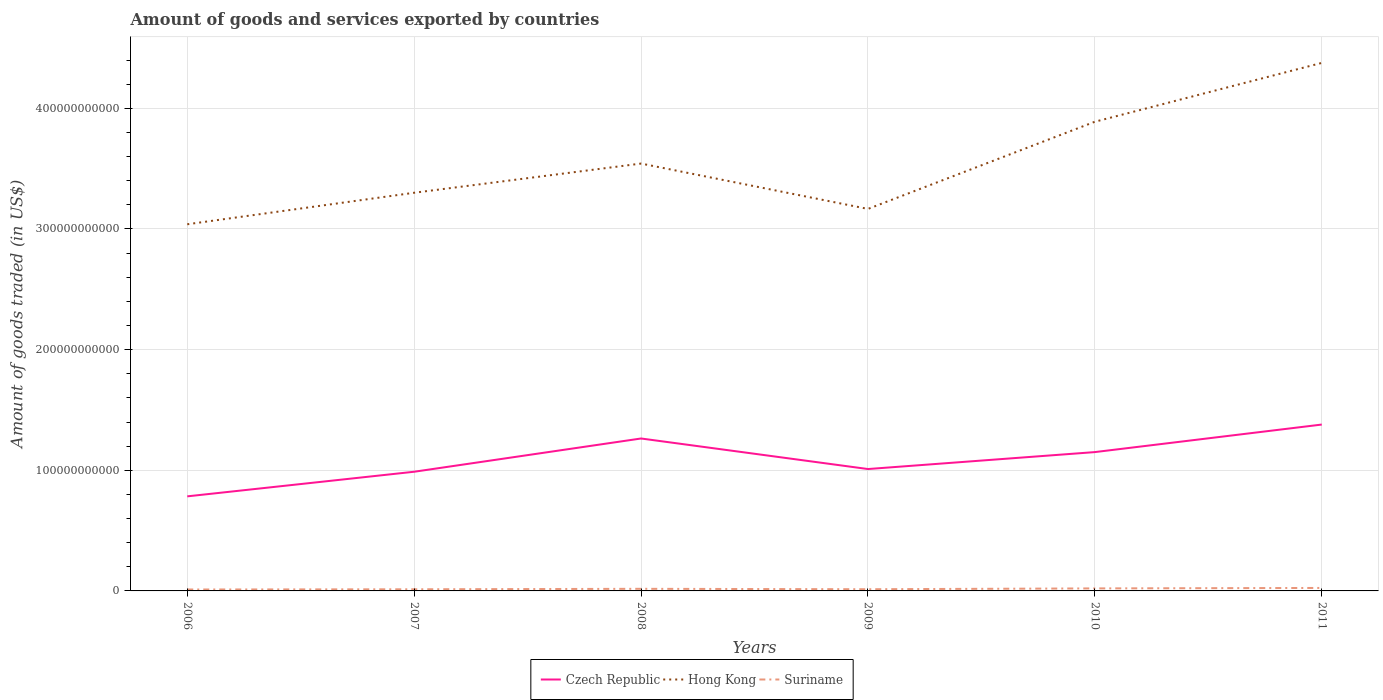How many different coloured lines are there?
Provide a succinct answer. 3. Across all years, what is the maximum total amount of goods and services exported in Hong Kong?
Your response must be concise. 3.04e+11. What is the total total amount of goods and services exported in Czech Republic in the graph?
Provide a short and direct response. -2.76e+1. What is the difference between the highest and the second highest total amount of goods and services exported in Suriname?
Offer a terse response. 1.29e+09. How many years are there in the graph?
Give a very brief answer. 6. What is the difference between two consecutive major ticks on the Y-axis?
Your answer should be very brief. 1.00e+11. Are the values on the major ticks of Y-axis written in scientific E-notation?
Provide a succinct answer. No. How many legend labels are there?
Your response must be concise. 3. How are the legend labels stacked?
Keep it short and to the point. Horizontal. What is the title of the graph?
Provide a short and direct response. Amount of goods and services exported by countries. What is the label or title of the Y-axis?
Your answer should be compact. Amount of goods traded (in US$). What is the Amount of goods traded (in US$) in Czech Republic in 2006?
Give a very brief answer. 7.84e+1. What is the Amount of goods traded (in US$) of Hong Kong in 2006?
Give a very brief answer. 3.04e+11. What is the Amount of goods traded (in US$) of Suriname in 2006?
Your answer should be compact. 1.17e+09. What is the Amount of goods traded (in US$) of Czech Republic in 2007?
Your answer should be very brief. 9.88e+1. What is the Amount of goods traded (in US$) of Hong Kong in 2007?
Offer a terse response. 3.30e+11. What is the Amount of goods traded (in US$) of Suriname in 2007?
Your answer should be compact. 1.36e+09. What is the Amount of goods traded (in US$) in Czech Republic in 2008?
Offer a very short reply. 1.26e+11. What is the Amount of goods traded (in US$) in Hong Kong in 2008?
Ensure brevity in your answer.  3.54e+11. What is the Amount of goods traded (in US$) in Suriname in 2008?
Provide a short and direct response. 1.74e+09. What is the Amount of goods traded (in US$) of Czech Republic in 2009?
Keep it short and to the point. 1.01e+11. What is the Amount of goods traded (in US$) in Hong Kong in 2009?
Your answer should be compact. 3.17e+11. What is the Amount of goods traded (in US$) in Suriname in 2009?
Keep it short and to the point. 1.40e+09. What is the Amount of goods traded (in US$) in Czech Republic in 2010?
Make the answer very short. 1.15e+11. What is the Amount of goods traded (in US$) in Hong Kong in 2010?
Keep it short and to the point. 3.89e+11. What is the Amount of goods traded (in US$) of Suriname in 2010?
Offer a terse response. 2.08e+09. What is the Amount of goods traded (in US$) in Czech Republic in 2011?
Keep it short and to the point. 1.38e+11. What is the Amount of goods traded (in US$) of Hong Kong in 2011?
Provide a succinct answer. 4.38e+11. What is the Amount of goods traded (in US$) of Suriname in 2011?
Provide a succinct answer. 2.47e+09. Across all years, what is the maximum Amount of goods traded (in US$) in Czech Republic?
Offer a very short reply. 1.38e+11. Across all years, what is the maximum Amount of goods traded (in US$) in Hong Kong?
Your answer should be compact. 4.38e+11. Across all years, what is the maximum Amount of goods traded (in US$) in Suriname?
Provide a short and direct response. 2.47e+09. Across all years, what is the minimum Amount of goods traded (in US$) of Czech Republic?
Provide a short and direct response. 7.84e+1. Across all years, what is the minimum Amount of goods traded (in US$) of Hong Kong?
Offer a terse response. 3.04e+11. Across all years, what is the minimum Amount of goods traded (in US$) in Suriname?
Give a very brief answer. 1.17e+09. What is the total Amount of goods traded (in US$) of Czech Republic in the graph?
Provide a short and direct response. 6.58e+11. What is the total Amount of goods traded (in US$) in Hong Kong in the graph?
Your answer should be very brief. 2.13e+12. What is the total Amount of goods traded (in US$) of Suriname in the graph?
Offer a very short reply. 1.02e+1. What is the difference between the Amount of goods traded (in US$) in Czech Republic in 2006 and that in 2007?
Give a very brief answer. -2.04e+1. What is the difference between the Amount of goods traded (in US$) in Hong Kong in 2006 and that in 2007?
Give a very brief answer. -2.61e+1. What is the difference between the Amount of goods traded (in US$) of Suriname in 2006 and that in 2007?
Offer a very short reply. -1.84e+08. What is the difference between the Amount of goods traded (in US$) of Czech Republic in 2006 and that in 2008?
Offer a very short reply. -4.80e+1. What is the difference between the Amount of goods traded (in US$) in Hong Kong in 2006 and that in 2008?
Your response must be concise. -5.03e+1. What is the difference between the Amount of goods traded (in US$) of Suriname in 2006 and that in 2008?
Make the answer very short. -5.69e+08. What is the difference between the Amount of goods traded (in US$) of Czech Republic in 2006 and that in 2009?
Give a very brief answer. -2.26e+1. What is the difference between the Amount of goods traded (in US$) of Hong Kong in 2006 and that in 2009?
Provide a succinct answer. -1.27e+1. What is the difference between the Amount of goods traded (in US$) in Suriname in 2006 and that in 2009?
Provide a short and direct response. -2.27e+08. What is the difference between the Amount of goods traded (in US$) in Czech Republic in 2006 and that in 2010?
Your response must be concise. -3.67e+1. What is the difference between the Amount of goods traded (in US$) in Hong Kong in 2006 and that in 2010?
Your answer should be very brief. -8.50e+1. What is the difference between the Amount of goods traded (in US$) of Suriname in 2006 and that in 2010?
Offer a very short reply. -9.10e+08. What is the difference between the Amount of goods traded (in US$) of Czech Republic in 2006 and that in 2011?
Your answer should be compact. -5.95e+1. What is the difference between the Amount of goods traded (in US$) in Hong Kong in 2006 and that in 2011?
Keep it short and to the point. -1.34e+11. What is the difference between the Amount of goods traded (in US$) of Suriname in 2006 and that in 2011?
Make the answer very short. -1.29e+09. What is the difference between the Amount of goods traded (in US$) of Czech Republic in 2007 and that in 2008?
Your answer should be very brief. -2.76e+1. What is the difference between the Amount of goods traded (in US$) in Hong Kong in 2007 and that in 2008?
Your answer should be very brief. -2.42e+1. What is the difference between the Amount of goods traded (in US$) in Suriname in 2007 and that in 2008?
Your answer should be compact. -3.84e+08. What is the difference between the Amount of goods traded (in US$) in Czech Republic in 2007 and that in 2009?
Offer a very short reply. -2.24e+09. What is the difference between the Amount of goods traded (in US$) of Hong Kong in 2007 and that in 2009?
Offer a very short reply. 1.34e+1. What is the difference between the Amount of goods traded (in US$) of Suriname in 2007 and that in 2009?
Offer a terse response. -4.28e+07. What is the difference between the Amount of goods traded (in US$) in Czech Republic in 2007 and that in 2010?
Keep it short and to the point. -1.63e+1. What is the difference between the Amount of goods traded (in US$) in Hong Kong in 2007 and that in 2010?
Make the answer very short. -5.89e+1. What is the difference between the Amount of goods traded (in US$) of Suriname in 2007 and that in 2010?
Provide a succinct answer. -7.25e+08. What is the difference between the Amount of goods traded (in US$) of Czech Republic in 2007 and that in 2011?
Your answer should be compact. -3.91e+1. What is the difference between the Amount of goods traded (in US$) of Hong Kong in 2007 and that in 2011?
Give a very brief answer. -1.08e+11. What is the difference between the Amount of goods traded (in US$) of Suriname in 2007 and that in 2011?
Your answer should be compact. -1.11e+09. What is the difference between the Amount of goods traded (in US$) in Czech Republic in 2008 and that in 2009?
Your answer should be very brief. 2.53e+1. What is the difference between the Amount of goods traded (in US$) in Hong Kong in 2008 and that in 2009?
Your answer should be compact. 3.76e+1. What is the difference between the Amount of goods traded (in US$) of Suriname in 2008 and that in 2009?
Provide a short and direct response. 3.42e+08. What is the difference between the Amount of goods traded (in US$) of Czech Republic in 2008 and that in 2010?
Offer a very short reply. 1.13e+1. What is the difference between the Amount of goods traded (in US$) of Hong Kong in 2008 and that in 2010?
Your response must be concise. -3.47e+1. What is the difference between the Amount of goods traded (in US$) of Suriname in 2008 and that in 2010?
Keep it short and to the point. -3.41e+08. What is the difference between the Amount of goods traded (in US$) in Czech Republic in 2008 and that in 2011?
Ensure brevity in your answer.  -1.15e+1. What is the difference between the Amount of goods traded (in US$) in Hong Kong in 2008 and that in 2011?
Make the answer very short. -8.34e+1. What is the difference between the Amount of goods traded (in US$) in Suriname in 2008 and that in 2011?
Offer a very short reply. -7.23e+08. What is the difference between the Amount of goods traded (in US$) in Czech Republic in 2009 and that in 2010?
Give a very brief answer. -1.40e+1. What is the difference between the Amount of goods traded (in US$) in Hong Kong in 2009 and that in 2010?
Your answer should be compact. -7.23e+1. What is the difference between the Amount of goods traded (in US$) in Suriname in 2009 and that in 2010?
Make the answer very short. -6.82e+08. What is the difference between the Amount of goods traded (in US$) of Czech Republic in 2009 and that in 2011?
Your answer should be compact. -3.69e+1. What is the difference between the Amount of goods traded (in US$) in Hong Kong in 2009 and that in 2011?
Give a very brief answer. -1.21e+11. What is the difference between the Amount of goods traded (in US$) of Suriname in 2009 and that in 2011?
Offer a terse response. -1.06e+09. What is the difference between the Amount of goods traded (in US$) in Czech Republic in 2010 and that in 2011?
Your answer should be very brief. -2.28e+1. What is the difference between the Amount of goods traded (in US$) in Hong Kong in 2010 and that in 2011?
Your answer should be compact. -4.88e+1. What is the difference between the Amount of goods traded (in US$) of Suriname in 2010 and that in 2011?
Provide a short and direct response. -3.83e+08. What is the difference between the Amount of goods traded (in US$) in Czech Republic in 2006 and the Amount of goods traded (in US$) in Hong Kong in 2007?
Your response must be concise. -2.52e+11. What is the difference between the Amount of goods traded (in US$) in Czech Republic in 2006 and the Amount of goods traded (in US$) in Suriname in 2007?
Provide a succinct answer. 7.70e+1. What is the difference between the Amount of goods traded (in US$) in Hong Kong in 2006 and the Amount of goods traded (in US$) in Suriname in 2007?
Offer a very short reply. 3.03e+11. What is the difference between the Amount of goods traded (in US$) in Czech Republic in 2006 and the Amount of goods traded (in US$) in Hong Kong in 2008?
Ensure brevity in your answer.  -2.76e+11. What is the difference between the Amount of goods traded (in US$) of Czech Republic in 2006 and the Amount of goods traded (in US$) of Suriname in 2008?
Give a very brief answer. 7.66e+1. What is the difference between the Amount of goods traded (in US$) of Hong Kong in 2006 and the Amount of goods traded (in US$) of Suriname in 2008?
Your answer should be compact. 3.02e+11. What is the difference between the Amount of goods traded (in US$) in Czech Republic in 2006 and the Amount of goods traded (in US$) in Hong Kong in 2009?
Ensure brevity in your answer.  -2.38e+11. What is the difference between the Amount of goods traded (in US$) of Czech Republic in 2006 and the Amount of goods traded (in US$) of Suriname in 2009?
Offer a very short reply. 7.70e+1. What is the difference between the Amount of goods traded (in US$) of Hong Kong in 2006 and the Amount of goods traded (in US$) of Suriname in 2009?
Give a very brief answer. 3.03e+11. What is the difference between the Amount of goods traded (in US$) of Czech Republic in 2006 and the Amount of goods traded (in US$) of Hong Kong in 2010?
Ensure brevity in your answer.  -3.11e+11. What is the difference between the Amount of goods traded (in US$) of Czech Republic in 2006 and the Amount of goods traded (in US$) of Suriname in 2010?
Provide a succinct answer. 7.63e+1. What is the difference between the Amount of goods traded (in US$) of Hong Kong in 2006 and the Amount of goods traded (in US$) of Suriname in 2010?
Offer a very short reply. 3.02e+11. What is the difference between the Amount of goods traded (in US$) of Czech Republic in 2006 and the Amount of goods traded (in US$) of Hong Kong in 2011?
Provide a short and direct response. -3.59e+11. What is the difference between the Amount of goods traded (in US$) of Czech Republic in 2006 and the Amount of goods traded (in US$) of Suriname in 2011?
Make the answer very short. 7.59e+1. What is the difference between the Amount of goods traded (in US$) of Hong Kong in 2006 and the Amount of goods traded (in US$) of Suriname in 2011?
Offer a very short reply. 3.01e+11. What is the difference between the Amount of goods traded (in US$) of Czech Republic in 2007 and the Amount of goods traded (in US$) of Hong Kong in 2008?
Make the answer very short. -2.55e+11. What is the difference between the Amount of goods traded (in US$) of Czech Republic in 2007 and the Amount of goods traded (in US$) of Suriname in 2008?
Ensure brevity in your answer.  9.70e+1. What is the difference between the Amount of goods traded (in US$) in Hong Kong in 2007 and the Amount of goods traded (in US$) in Suriname in 2008?
Offer a very short reply. 3.28e+11. What is the difference between the Amount of goods traded (in US$) in Czech Republic in 2007 and the Amount of goods traded (in US$) in Hong Kong in 2009?
Your answer should be compact. -2.18e+11. What is the difference between the Amount of goods traded (in US$) in Czech Republic in 2007 and the Amount of goods traded (in US$) in Suriname in 2009?
Provide a short and direct response. 9.74e+1. What is the difference between the Amount of goods traded (in US$) in Hong Kong in 2007 and the Amount of goods traded (in US$) in Suriname in 2009?
Offer a very short reply. 3.29e+11. What is the difference between the Amount of goods traded (in US$) in Czech Republic in 2007 and the Amount of goods traded (in US$) in Hong Kong in 2010?
Make the answer very short. -2.90e+11. What is the difference between the Amount of goods traded (in US$) in Czech Republic in 2007 and the Amount of goods traded (in US$) in Suriname in 2010?
Your answer should be compact. 9.67e+1. What is the difference between the Amount of goods traded (in US$) in Hong Kong in 2007 and the Amount of goods traded (in US$) in Suriname in 2010?
Give a very brief answer. 3.28e+11. What is the difference between the Amount of goods traded (in US$) of Czech Republic in 2007 and the Amount of goods traded (in US$) of Hong Kong in 2011?
Keep it short and to the point. -3.39e+11. What is the difference between the Amount of goods traded (in US$) in Czech Republic in 2007 and the Amount of goods traded (in US$) in Suriname in 2011?
Provide a succinct answer. 9.63e+1. What is the difference between the Amount of goods traded (in US$) in Hong Kong in 2007 and the Amount of goods traded (in US$) in Suriname in 2011?
Your answer should be very brief. 3.28e+11. What is the difference between the Amount of goods traded (in US$) of Czech Republic in 2008 and the Amount of goods traded (in US$) of Hong Kong in 2009?
Provide a succinct answer. -1.90e+11. What is the difference between the Amount of goods traded (in US$) of Czech Republic in 2008 and the Amount of goods traded (in US$) of Suriname in 2009?
Offer a very short reply. 1.25e+11. What is the difference between the Amount of goods traded (in US$) in Hong Kong in 2008 and the Amount of goods traded (in US$) in Suriname in 2009?
Give a very brief answer. 3.53e+11. What is the difference between the Amount of goods traded (in US$) of Czech Republic in 2008 and the Amount of goods traded (in US$) of Hong Kong in 2010?
Offer a terse response. -2.63e+11. What is the difference between the Amount of goods traded (in US$) of Czech Republic in 2008 and the Amount of goods traded (in US$) of Suriname in 2010?
Your answer should be very brief. 1.24e+11. What is the difference between the Amount of goods traded (in US$) in Hong Kong in 2008 and the Amount of goods traded (in US$) in Suriname in 2010?
Offer a very short reply. 3.52e+11. What is the difference between the Amount of goods traded (in US$) of Czech Republic in 2008 and the Amount of goods traded (in US$) of Hong Kong in 2011?
Ensure brevity in your answer.  -3.11e+11. What is the difference between the Amount of goods traded (in US$) in Czech Republic in 2008 and the Amount of goods traded (in US$) in Suriname in 2011?
Give a very brief answer. 1.24e+11. What is the difference between the Amount of goods traded (in US$) of Hong Kong in 2008 and the Amount of goods traded (in US$) of Suriname in 2011?
Provide a short and direct response. 3.52e+11. What is the difference between the Amount of goods traded (in US$) in Czech Republic in 2009 and the Amount of goods traded (in US$) in Hong Kong in 2010?
Provide a succinct answer. -2.88e+11. What is the difference between the Amount of goods traded (in US$) in Czech Republic in 2009 and the Amount of goods traded (in US$) in Suriname in 2010?
Make the answer very short. 9.89e+1. What is the difference between the Amount of goods traded (in US$) in Hong Kong in 2009 and the Amount of goods traded (in US$) in Suriname in 2010?
Your answer should be compact. 3.15e+11. What is the difference between the Amount of goods traded (in US$) of Czech Republic in 2009 and the Amount of goods traded (in US$) of Hong Kong in 2011?
Offer a terse response. -3.37e+11. What is the difference between the Amount of goods traded (in US$) in Czech Republic in 2009 and the Amount of goods traded (in US$) in Suriname in 2011?
Provide a succinct answer. 9.86e+1. What is the difference between the Amount of goods traded (in US$) in Hong Kong in 2009 and the Amount of goods traded (in US$) in Suriname in 2011?
Ensure brevity in your answer.  3.14e+11. What is the difference between the Amount of goods traded (in US$) of Czech Republic in 2010 and the Amount of goods traded (in US$) of Hong Kong in 2011?
Your answer should be very brief. -3.23e+11. What is the difference between the Amount of goods traded (in US$) in Czech Republic in 2010 and the Amount of goods traded (in US$) in Suriname in 2011?
Keep it short and to the point. 1.13e+11. What is the difference between the Amount of goods traded (in US$) in Hong Kong in 2010 and the Amount of goods traded (in US$) in Suriname in 2011?
Make the answer very short. 3.86e+11. What is the average Amount of goods traded (in US$) in Czech Republic per year?
Your answer should be very brief. 1.10e+11. What is the average Amount of goods traded (in US$) in Hong Kong per year?
Offer a very short reply. 3.55e+11. What is the average Amount of goods traded (in US$) in Suriname per year?
Make the answer very short. 1.70e+09. In the year 2006, what is the difference between the Amount of goods traded (in US$) in Czech Republic and Amount of goods traded (in US$) in Hong Kong?
Your answer should be compact. -2.26e+11. In the year 2006, what is the difference between the Amount of goods traded (in US$) in Czech Republic and Amount of goods traded (in US$) in Suriname?
Provide a short and direct response. 7.72e+1. In the year 2006, what is the difference between the Amount of goods traded (in US$) in Hong Kong and Amount of goods traded (in US$) in Suriname?
Provide a short and direct response. 3.03e+11. In the year 2007, what is the difference between the Amount of goods traded (in US$) in Czech Republic and Amount of goods traded (in US$) in Hong Kong?
Your answer should be very brief. -2.31e+11. In the year 2007, what is the difference between the Amount of goods traded (in US$) of Czech Republic and Amount of goods traded (in US$) of Suriname?
Offer a very short reply. 9.74e+1. In the year 2007, what is the difference between the Amount of goods traded (in US$) of Hong Kong and Amount of goods traded (in US$) of Suriname?
Give a very brief answer. 3.29e+11. In the year 2008, what is the difference between the Amount of goods traded (in US$) in Czech Republic and Amount of goods traded (in US$) in Hong Kong?
Your answer should be very brief. -2.28e+11. In the year 2008, what is the difference between the Amount of goods traded (in US$) of Czech Republic and Amount of goods traded (in US$) of Suriname?
Ensure brevity in your answer.  1.25e+11. In the year 2008, what is the difference between the Amount of goods traded (in US$) of Hong Kong and Amount of goods traded (in US$) of Suriname?
Provide a short and direct response. 3.52e+11. In the year 2009, what is the difference between the Amount of goods traded (in US$) in Czech Republic and Amount of goods traded (in US$) in Hong Kong?
Give a very brief answer. -2.16e+11. In the year 2009, what is the difference between the Amount of goods traded (in US$) of Czech Republic and Amount of goods traded (in US$) of Suriname?
Offer a terse response. 9.96e+1. In the year 2009, what is the difference between the Amount of goods traded (in US$) of Hong Kong and Amount of goods traded (in US$) of Suriname?
Offer a terse response. 3.15e+11. In the year 2010, what is the difference between the Amount of goods traded (in US$) in Czech Republic and Amount of goods traded (in US$) in Hong Kong?
Your answer should be compact. -2.74e+11. In the year 2010, what is the difference between the Amount of goods traded (in US$) of Czech Republic and Amount of goods traded (in US$) of Suriname?
Ensure brevity in your answer.  1.13e+11. In the year 2010, what is the difference between the Amount of goods traded (in US$) in Hong Kong and Amount of goods traded (in US$) in Suriname?
Your answer should be very brief. 3.87e+11. In the year 2011, what is the difference between the Amount of goods traded (in US$) in Czech Republic and Amount of goods traded (in US$) in Hong Kong?
Give a very brief answer. -3.00e+11. In the year 2011, what is the difference between the Amount of goods traded (in US$) in Czech Republic and Amount of goods traded (in US$) in Suriname?
Make the answer very short. 1.35e+11. In the year 2011, what is the difference between the Amount of goods traded (in US$) of Hong Kong and Amount of goods traded (in US$) of Suriname?
Provide a short and direct response. 4.35e+11. What is the ratio of the Amount of goods traded (in US$) in Czech Republic in 2006 to that in 2007?
Give a very brief answer. 0.79. What is the ratio of the Amount of goods traded (in US$) of Hong Kong in 2006 to that in 2007?
Keep it short and to the point. 0.92. What is the ratio of the Amount of goods traded (in US$) in Suriname in 2006 to that in 2007?
Ensure brevity in your answer.  0.86. What is the ratio of the Amount of goods traded (in US$) in Czech Republic in 2006 to that in 2008?
Make the answer very short. 0.62. What is the ratio of the Amount of goods traded (in US$) in Hong Kong in 2006 to that in 2008?
Provide a succinct answer. 0.86. What is the ratio of the Amount of goods traded (in US$) in Suriname in 2006 to that in 2008?
Offer a terse response. 0.67. What is the ratio of the Amount of goods traded (in US$) in Czech Republic in 2006 to that in 2009?
Keep it short and to the point. 0.78. What is the ratio of the Amount of goods traded (in US$) in Hong Kong in 2006 to that in 2009?
Make the answer very short. 0.96. What is the ratio of the Amount of goods traded (in US$) in Suriname in 2006 to that in 2009?
Make the answer very short. 0.84. What is the ratio of the Amount of goods traded (in US$) in Czech Republic in 2006 to that in 2010?
Make the answer very short. 0.68. What is the ratio of the Amount of goods traded (in US$) in Hong Kong in 2006 to that in 2010?
Your response must be concise. 0.78. What is the ratio of the Amount of goods traded (in US$) of Suriname in 2006 to that in 2010?
Your answer should be compact. 0.56. What is the ratio of the Amount of goods traded (in US$) of Czech Republic in 2006 to that in 2011?
Give a very brief answer. 0.57. What is the ratio of the Amount of goods traded (in US$) of Hong Kong in 2006 to that in 2011?
Ensure brevity in your answer.  0.69. What is the ratio of the Amount of goods traded (in US$) in Suriname in 2006 to that in 2011?
Offer a terse response. 0.48. What is the ratio of the Amount of goods traded (in US$) of Czech Republic in 2007 to that in 2008?
Ensure brevity in your answer.  0.78. What is the ratio of the Amount of goods traded (in US$) of Hong Kong in 2007 to that in 2008?
Give a very brief answer. 0.93. What is the ratio of the Amount of goods traded (in US$) of Suriname in 2007 to that in 2008?
Your response must be concise. 0.78. What is the ratio of the Amount of goods traded (in US$) in Czech Republic in 2007 to that in 2009?
Provide a succinct answer. 0.98. What is the ratio of the Amount of goods traded (in US$) of Hong Kong in 2007 to that in 2009?
Make the answer very short. 1.04. What is the ratio of the Amount of goods traded (in US$) of Suriname in 2007 to that in 2009?
Your answer should be compact. 0.97. What is the ratio of the Amount of goods traded (in US$) of Czech Republic in 2007 to that in 2010?
Ensure brevity in your answer.  0.86. What is the ratio of the Amount of goods traded (in US$) in Hong Kong in 2007 to that in 2010?
Your answer should be compact. 0.85. What is the ratio of the Amount of goods traded (in US$) of Suriname in 2007 to that in 2010?
Make the answer very short. 0.65. What is the ratio of the Amount of goods traded (in US$) of Czech Republic in 2007 to that in 2011?
Make the answer very short. 0.72. What is the ratio of the Amount of goods traded (in US$) in Hong Kong in 2007 to that in 2011?
Ensure brevity in your answer.  0.75. What is the ratio of the Amount of goods traded (in US$) of Suriname in 2007 to that in 2011?
Provide a succinct answer. 0.55. What is the ratio of the Amount of goods traded (in US$) of Czech Republic in 2008 to that in 2009?
Provide a short and direct response. 1.25. What is the ratio of the Amount of goods traded (in US$) in Hong Kong in 2008 to that in 2009?
Your response must be concise. 1.12. What is the ratio of the Amount of goods traded (in US$) of Suriname in 2008 to that in 2009?
Ensure brevity in your answer.  1.24. What is the ratio of the Amount of goods traded (in US$) in Czech Republic in 2008 to that in 2010?
Provide a short and direct response. 1.1. What is the ratio of the Amount of goods traded (in US$) in Hong Kong in 2008 to that in 2010?
Your answer should be compact. 0.91. What is the ratio of the Amount of goods traded (in US$) in Suriname in 2008 to that in 2010?
Give a very brief answer. 0.84. What is the ratio of the Amount of goods traded (in US$) of Czech Republic in 2008 to that in 2011?
Provide a succinct answer. 0.92. What is the ratio of the Amount of goods traded (in US$) in Hong Kong in 2008 to that in 2011?
Your answer should be compact. 0.81. What is the ratio of the Amount of goods traded (in US$) in Suriname in 2008 to that in 2011?
Your answer should be very brief. 0.71. What is the ratio of the Amount of goods traded (in US$) of Czech Republic in 2009 to that in 2010?
Provide a short and direct response. 0.88. What is the ratio of the Amount of goods traded (in US$) in Hong Kong in 2009 to that in 2010?
Make the answer very short. 0.81. What is the ratio of the Amount of goods traded (in US$) of Suriname in 2009 to that in 2010?
Your response must be concise. 0.67. What is the ratio of the Amount of goods traded (in US$) of Czech Republic in 2009 to that in 2011?
Offer a terse response. 0.73. What is the ratio of the Amount of goods traded (in US$) in Hong Kong in 2009 to that in 2011?
Provide a short and direct response. 0.72. What is the ratio of the Amount of goods traded (in US$) in Suriname in 2009 to that in 2011?
Offer a terse response. 0.57. What is the ratio of the Amount of goods traded (in US$) of Czech Republic in 2010 to that in 2011?
Offer a terse response. 0.83. What is the ratio of the Amount of goods traded (in US$) in Hong Kong in 2010 to that in 2011?
Your response must be concise. 0.89. What is the ratio of the Amount of goods traded (in US$) of Suriname in 2010 to that in 2011?
Offer a terse response. 0.84. What is the difference between the highest and the second highest Amount of goods traded (in US$) in Czech Republic?
Your answer should be compact. 1.15e+1. What is the difference between the highest and the second highest Amount of goods traded (in US$) in Hong Kong?
Your answer should be compact. 4.88e+1. What is the difference between the highest and the second highest Amount of goods traded (in US$) in Suriname?
Give a very brief answer. 3.83e+08. What is the difference between the highest and the lowest Amount of goods traded (in US$) in Czech Republic?
Your answer should be compact. 5.95e+1. What is the difference between the highest and the lowest Amount of goods traded (in US$) of Hong Kong?
Provide a succinct answer. 1.34e+11. What is the difference between the highest and the lowest Amount of goods traded (in US$) in Suriname?
Provide a short and direct response. 1.29e+09. 